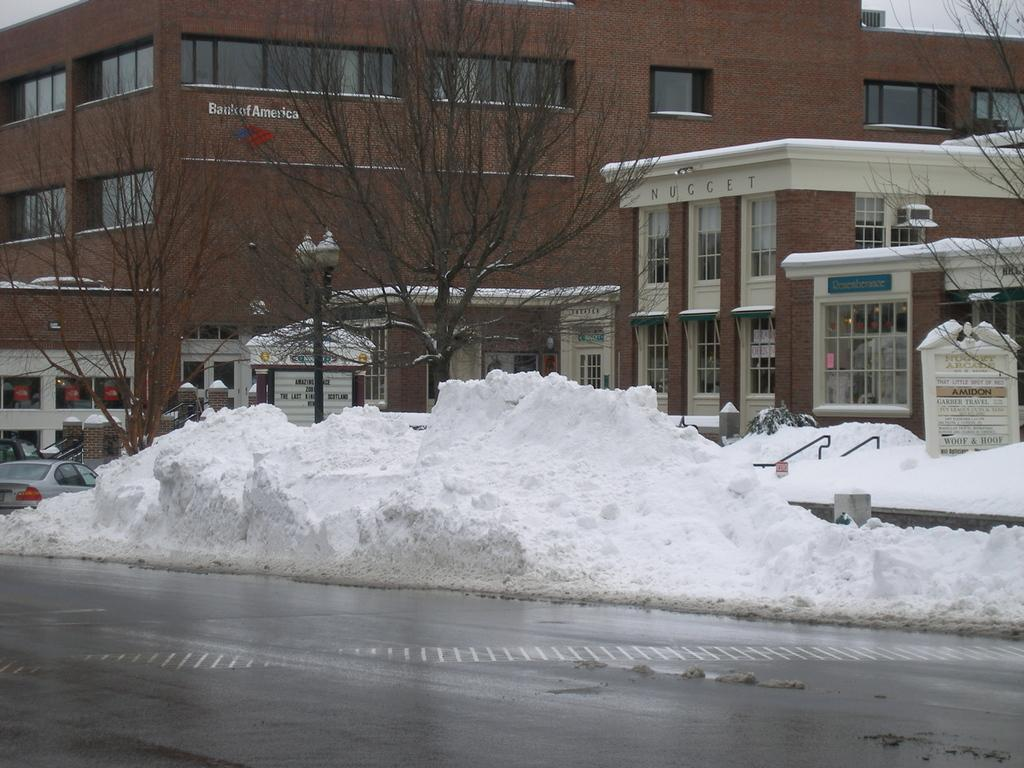What is the main feature of the image? There is a road in the image. What is the weather condition in the image? There is snow visible in the image. What can be seen in the background of the image? There are trees, a vehicle, and a building in the background of the image. How many chickens are crossing the road in the image? There are no chickens present in the image. What type of science experiment is being conducted in the image? There is no science experiment visible in the image. 